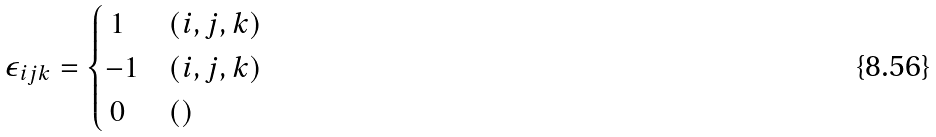Convert formula to latex. <formula><loc_0><loc_0><loc_500><loc_500>\epsilon _ { i j k } = \begin{cases} \, 1 & ( i , j , k ) \\ - 1 & ( i , j , k ) \\ \, 0 \, & ( ) \end{cases}</formula> 